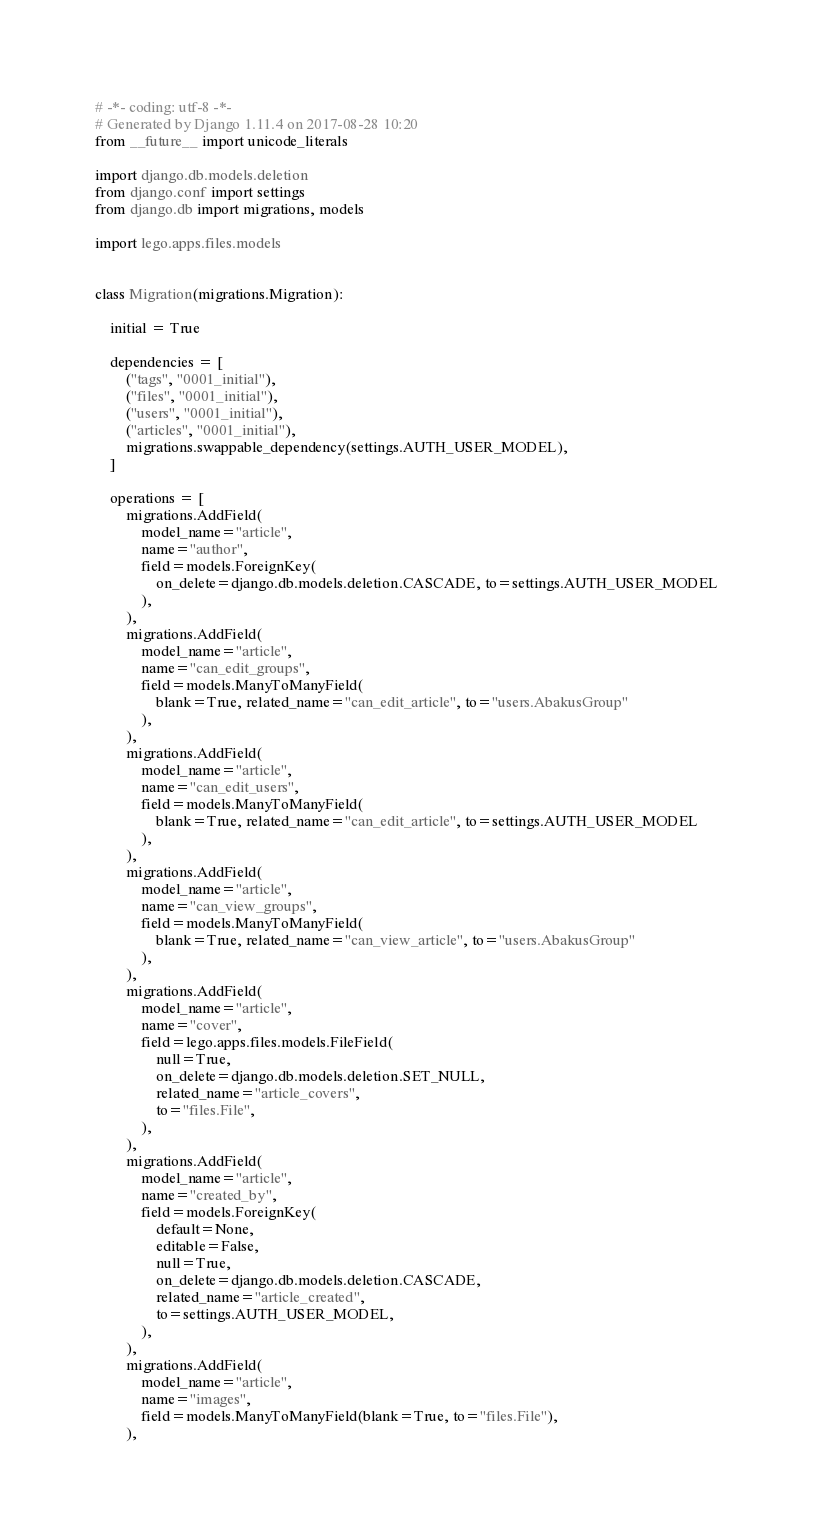<code> <loc_0><loc_0><loc_500><loc_500><_Python_># -*- coding: utf-8 -*-
# Generated by Django 1.11.4 on 2017-08-28 10:20
from __future__ import unicode_literals

import django.db.models.deletion
from django.conf import settings
from django.db import migrations, models

import lego.apps.files.models


class Migration(migrations.Migration):

    initial = True

    dependencies = [
        ("tags", "0001_initial"),
        ("files", "0001_initial"),
        ("users", "0001_initial"),
        ("articles", "0001_initial"),
        migrations.swappable_dependency(settings.AUTH_USER_MODEL),
    ]

    operations = [
        migrations.AddField(
            model_name="article",
            name="author",
            field=models.ForeignKey(
                on_delete=django.db.models.deletion.CASCADE, to=settings.AUTH_USER_MODEL
            ),
        ),
        migrations.AddField(
            model_name="article",
            name="can_edit_groups",
            field=models.ManyToManyField(
                blank=True, related_name="can_edit_article", to="users.AbakusGroup"
            ),
        ),
        migrations.AddField(
            model_name="article",
            name="can_edit_users",
            field=models.ManyToManyField(
                blank=True, related_name="can_edit_article", to=settings.AUTH_USER_MODEL
            ),
        ),
        migrations.AddField(
            model_name="article",
            name="can_view_groups",
            field=models.ManyToManyField(
                blank=True, related_name="can_view_article", to="users.AbakusGroup"
            ),
        ),
        migrations.AddField(
            model_name="article",
            name="cover",
            field=lego.apps.files.models.FileField(
                null=True,
                on_delete=django.db.models.deletion.SET_NULL,
                related_name="article_covers",
                to="files.File",
            ),
        ),
        migrations.AddField(
            model_name="article",
            name="created_by",
            field=models.ForeignKey(
                default=None,
                editable=False,
                null=True,
                on_delete=django.db.models.deletion.CASCADE,
                related_name="article_created",
                to=settings.AUTH_USER_MODEL,
            ),
        ),
        migrations.AddField(
            model_name="article",
            name="images",
            field=models.ManyToManyField(blank=True, to="files.File"),
        ),</code> 